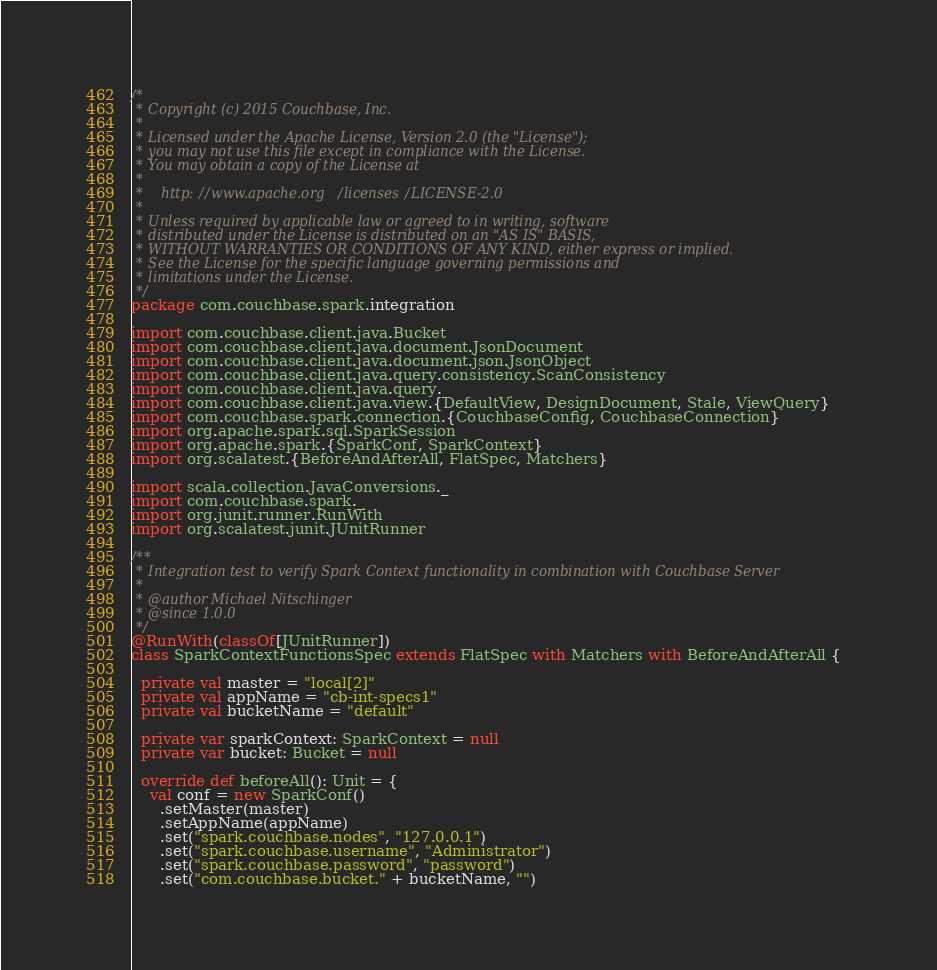Convert code to text. <code><loc_0><loc_0><loc_500><loc_500><_Scala_>/*
 * Copyright (c) 2015 Couchbase, Inc.
 *
 * Licensed under the Apache License, Version 2.0 (the "License");
 * you may not use this file except in compliance with the License.
 * You may obtain a copy of the License at
 *
 *    http://www.apache.org/licenses/LICENSE-2.0
 *
 * Unless required by applicable law or agreed to in writing, software
 * distributed under the License is distributed on an "AS IS" BASIS,
 * WITHOUT WARRANTIES OR CONDITIONS OF ANY KIND, either express or implied.
 * See the License for the specific language governing permissions and
 * limitations under the License.
 */
package com.couchbase.spark.integration

import com.couchbase.client.java.Bucket
import com.couchbase.client.java.document.JsonDocument
import com.couchbase.client.java.document.json.JsonObject
import com.couchbase.client.java.query.consistency.ScanConsistency
import com.couchbase.client.java.query._
import com.couchbase.client.java.view.{DefaultView, DesignDocument, Stale, ViewQuery}
import com.couchbase.spark.connection.{CouchbaseConfig, CouchbaseConnection}
import org.apache.spark.sql.SparkSession
import org.apache.spark.{SparkConf, SparkContext}
import org.scalatest.{BeforeAndAfterAll, FlatSpec, Matchers}

import scala.collection.JavaConversions._
import com.couchbase.spark._
import org.junit.runner.RunWith
import org.scalatest.junit.JUnitRunner

/**
 * Integration test to verify Spark Context functionality in combination with Couchbase Server
 *
 * @author Michael Nitschinger
 * @since 1.0.0
 */
@RunWith(classOf[JUnitRunner])
class SparkContextFunctionsSpec extends FlatSpec with Matchers with BeforeAndAfterAll {

  private val master = "local[2]"
  private val appName = "cb-int-specs1"
  private val bucketName = "default"

  private var sparkContext: SparkContext = null
  private var bucket: Bucket = null

  override def beforeAll(): Unit = {
    val conf = new SparkConf()
      .setMaster(master)
      .setAppName(appName)
      .set("spark.couchbase.nodes", "127.0.0.1")
      .set("spark.couchbase.username", "Administrator")
      .set("spark.couchbase.password", "password")
      .set("com.couchbase.bucket." + bucketName, "")</code> 